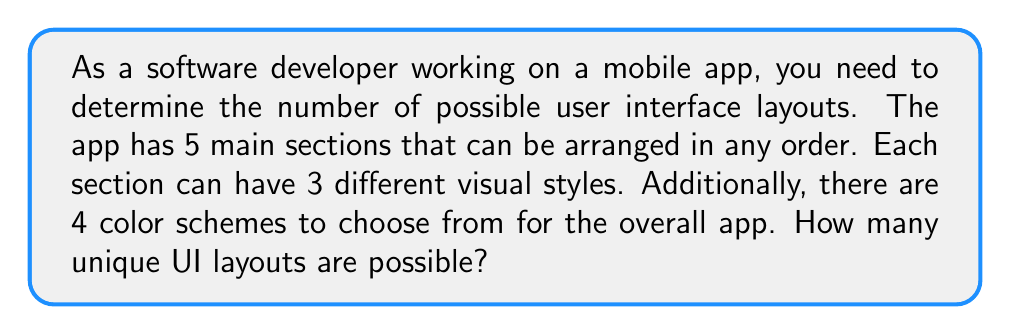What is the answer to this math problem? Let's break this down step-by-step:

1. Arrangement of main sections:
   There are 5 sections that can be arranged in any order. This is a permutation of 5 items, which is calculated as:
   $$5! = 5 \times 4 \times 3 \times 2 \times 1 = 120$$

2. Visual styles for each section:
   Each section can have 3 different styles. Since there are 5 sections, and the choice for each section is independent, we use the multiplication principle:
   $$3^5 = 243$$

3. Color schemes:
   There are 4 color schemes to choose from for the overall app.

4. Total number of combinations:
   To get the total number of possible layouts, we multiply these three factors together:
   $$120 \times 243 \times 4 = 116,640$$

Therefore, the total number of possible UI layouts is 116,640.
Answer: 116,640 